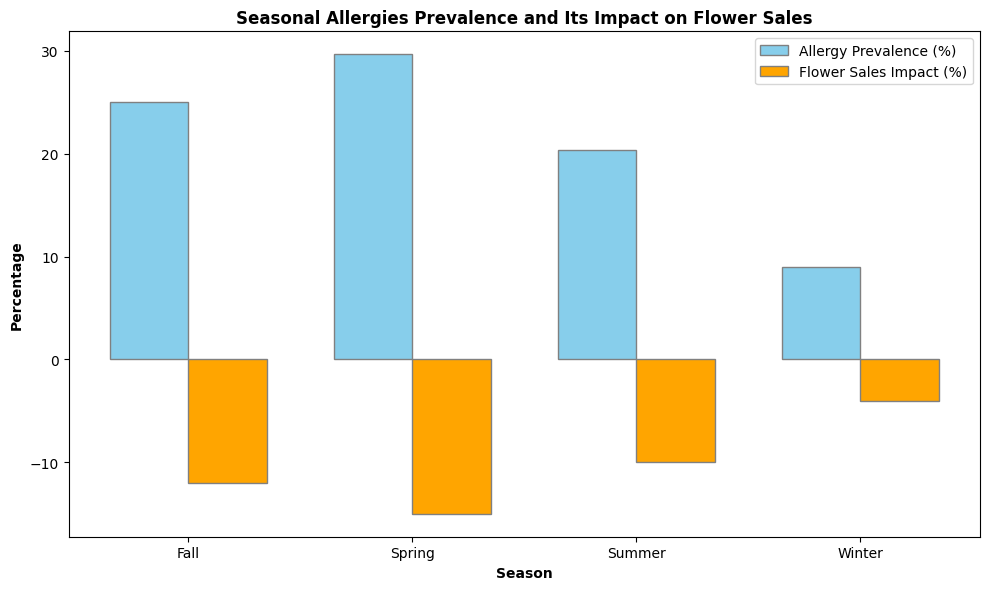What's the average allergy prevalence percentage for all seasons combined? To find the average allergy prevalence percentage for all seasons, sum the average percentages for each season and divide by the number of seasons. From the data: (30 + 20 + 25 + 10) / 4 = 85 / 4 = 21.25 for Spring, Summer, Fall, and Winter.
Answer: 21.25 In which season does allergy prevalence have the smallest impact on flower sales? By comparing the "Flower Sales Impact (%)" for each season, we find Winter shows the smallest impact at -4%.
Answer: Winter What is the difference in flower sales impact between Spring and Winter? The difference in "Flower Sales Impact (%)" between Spring and Winter is calculated as -15% (Spring) - (-4%) (Winter) = -15% + 4% = -11%.
Answer: 11% Which season has the highest average allergy prevalence percentage? By examining the height of the blue bars (allergy prevalence percentage) for each season, Spring has the highest average at around 30%.
Answer: Spring Compare the visual height of the bars for allergy prevalence percentage; which bar is approximately twice as high as another? Observing the chart, the blue bar for Winter (around 10%) is approximately half the height of the blue bar for Spring (around 30%).
Answer: Winter and Spring How much higher is the allergy prevalence percentage in Spring compared to Summer? The difference in average allergy prevalence percentage is 30% (Spring) - 20% (Summer) = 10%.
Answer: 10% Which season has a closer relationship between allergy prevalence percentage and flower sales impact percentage? By examining the visual gap between the blue and orange bars, Winter has closer values of 10% (allergy prevalence) and -4% (flower sales impact), indicating the smallest difference.
Answer: Winter What’s the sum of the average flower sales impact percentages across all seasons? Adding the average flower sales impact percentages for all seasons: -15% (Spring) + -10% (Summer) + -12% (Fall) + -5% (Winter) = -42%.
Answer: -42 Which two seasons have the smallest difference in allergy prevalence percentages? Comparing adjacent average allergy prevalence values: 30% (Spring) vs. 25% (Fall) gives a 5% difference, which is the smallest compared to the others.
Answer: Spring and Fall 